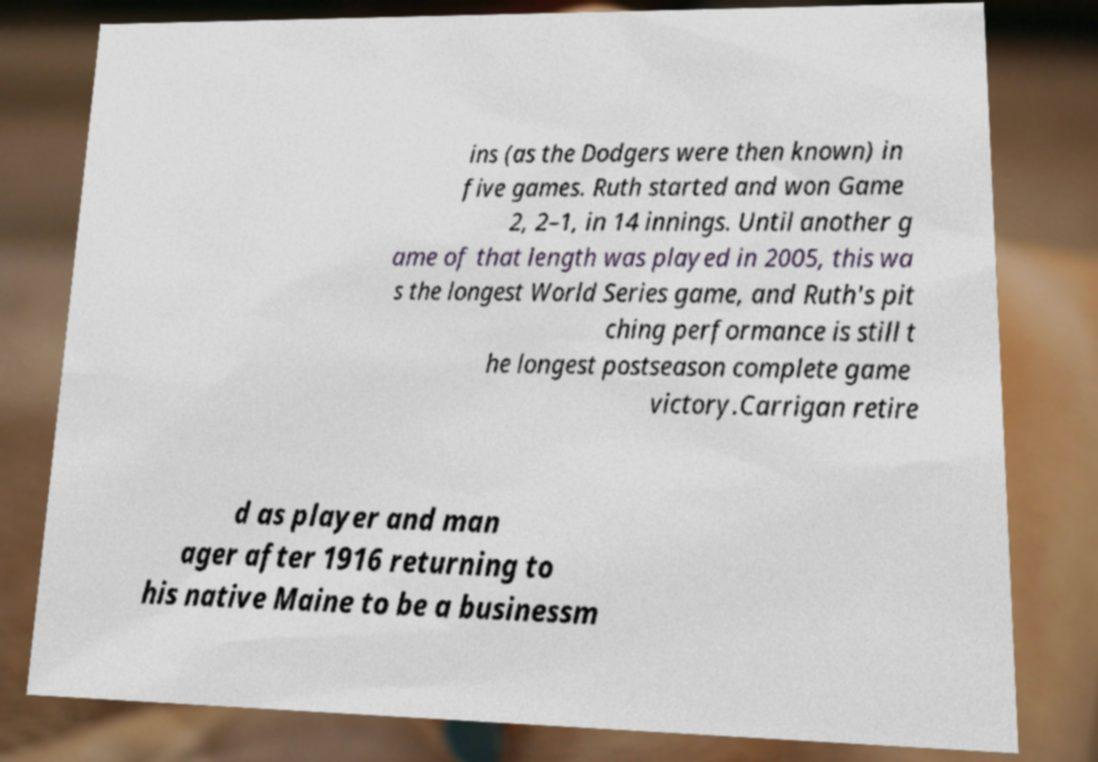Could you assist in decoding the text presented in this image and type it out clearly? ins (as the Dodgers were then known) in five games. Ruth started and won Game 2, 2–1, in 14 innings. Until another g ame of that length was played in 2005, this wa s the longest World Series game, and Ruth's pit ching performance is still t he longest postseason complete game victory.Carrigan retire d as player and man ager after 1916 returning to his native Maine to be a businessm 